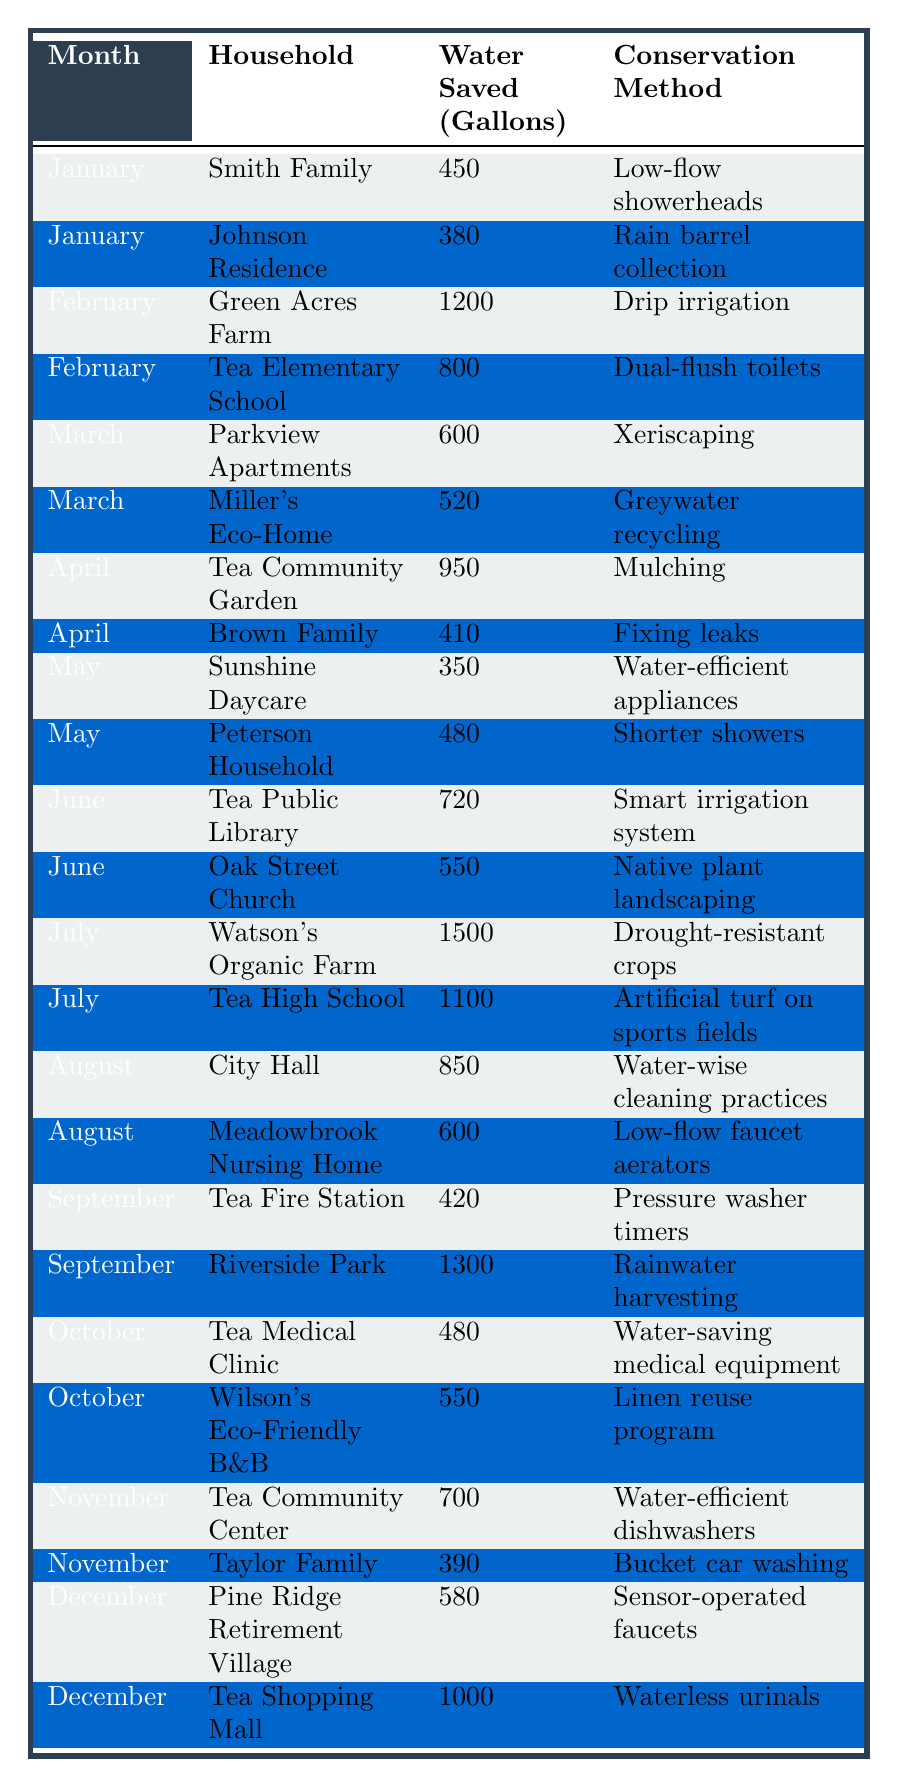What conservation method saved the most water in July? In July, the Watson's Organic Farm saved 1500 gallons, which is the highest in the month and the entire table.
Answer: Drought-resistant crops How much water did the Tea Community Center save in November? The Tea Community Center saved 700 gallons in November, as shown in the table.
Answer: 700 gallons Which household saved the least water in January? The Johnson Residence saved 380 gallons, making it the lowest amount saved compared to the Smith Family's 450 gallons.
Answer: Johnson Residence What is the total amount of water saved in August by both City Hall and Meadowbrook Nursing Home? City Hall saved 850 gallons and Meadowbrook Nursing Home saved 600 gallons. The total is 850 + 600 = 1450 gallons.
Answer: 1450 gallons How many households used low-flow fixtures in their water conservation methods? Two households used low-flow fixtures: the Smith Family used low-flow showerheads, and Meadowbrook Nursing Home used low-flow faucet aerators.
Answer: Two households What is the average amount of water saved across all months in the table? We total the saved water: 450 + 380 + 1200 + 800 + 600 + 520 + 950 + 410 + 350 + 480 + 720 + 550 + 1500 + 1100 + 850 + 600 + 420 + 1300 + 480 + 550 + 700 + 390 + 580 + 1000 = 10020 gallons. There are 24 entries, so the average is 10020 / 24 = 417.5 gallons.
Answer: 417.5 gallons Which method had the second highest water savings, and how much was saved? The second highest savings was for Tea High School, using artificial turf on sports fields, which saved 1100 gallons, after Watson's Organic Farm's 1500 gallons.
Answer: 1100 gallons Did any household save more than 1000 gallons in September? Yes, Riverside Park saved 1300 gallons, which is greater than 1000 gallons.
Answer: Yes How much more water did Green Acres Farm save compared to the Brown Family in April? Green Acres Farm saved 1200 gallons, while Brown Family saved 410 gallons. The difference is 1200 - 410 = 790 gallons.
Answer: 790 gallons What percentage of total water conserved came from the month of July? The total for July is 1500 + 1100 = 2600 gallons. Total water saved is 10020 gallons. The percentage is (2600/10020) * 100 = 25.92%.
Answer: 25.92% Which month had the overall lowest saving based on the table? The month of May had the lowest total, with 350 (Sunshine Daycare) + 480 (Peterson Household) = 830 gallons total.
Answer: May 